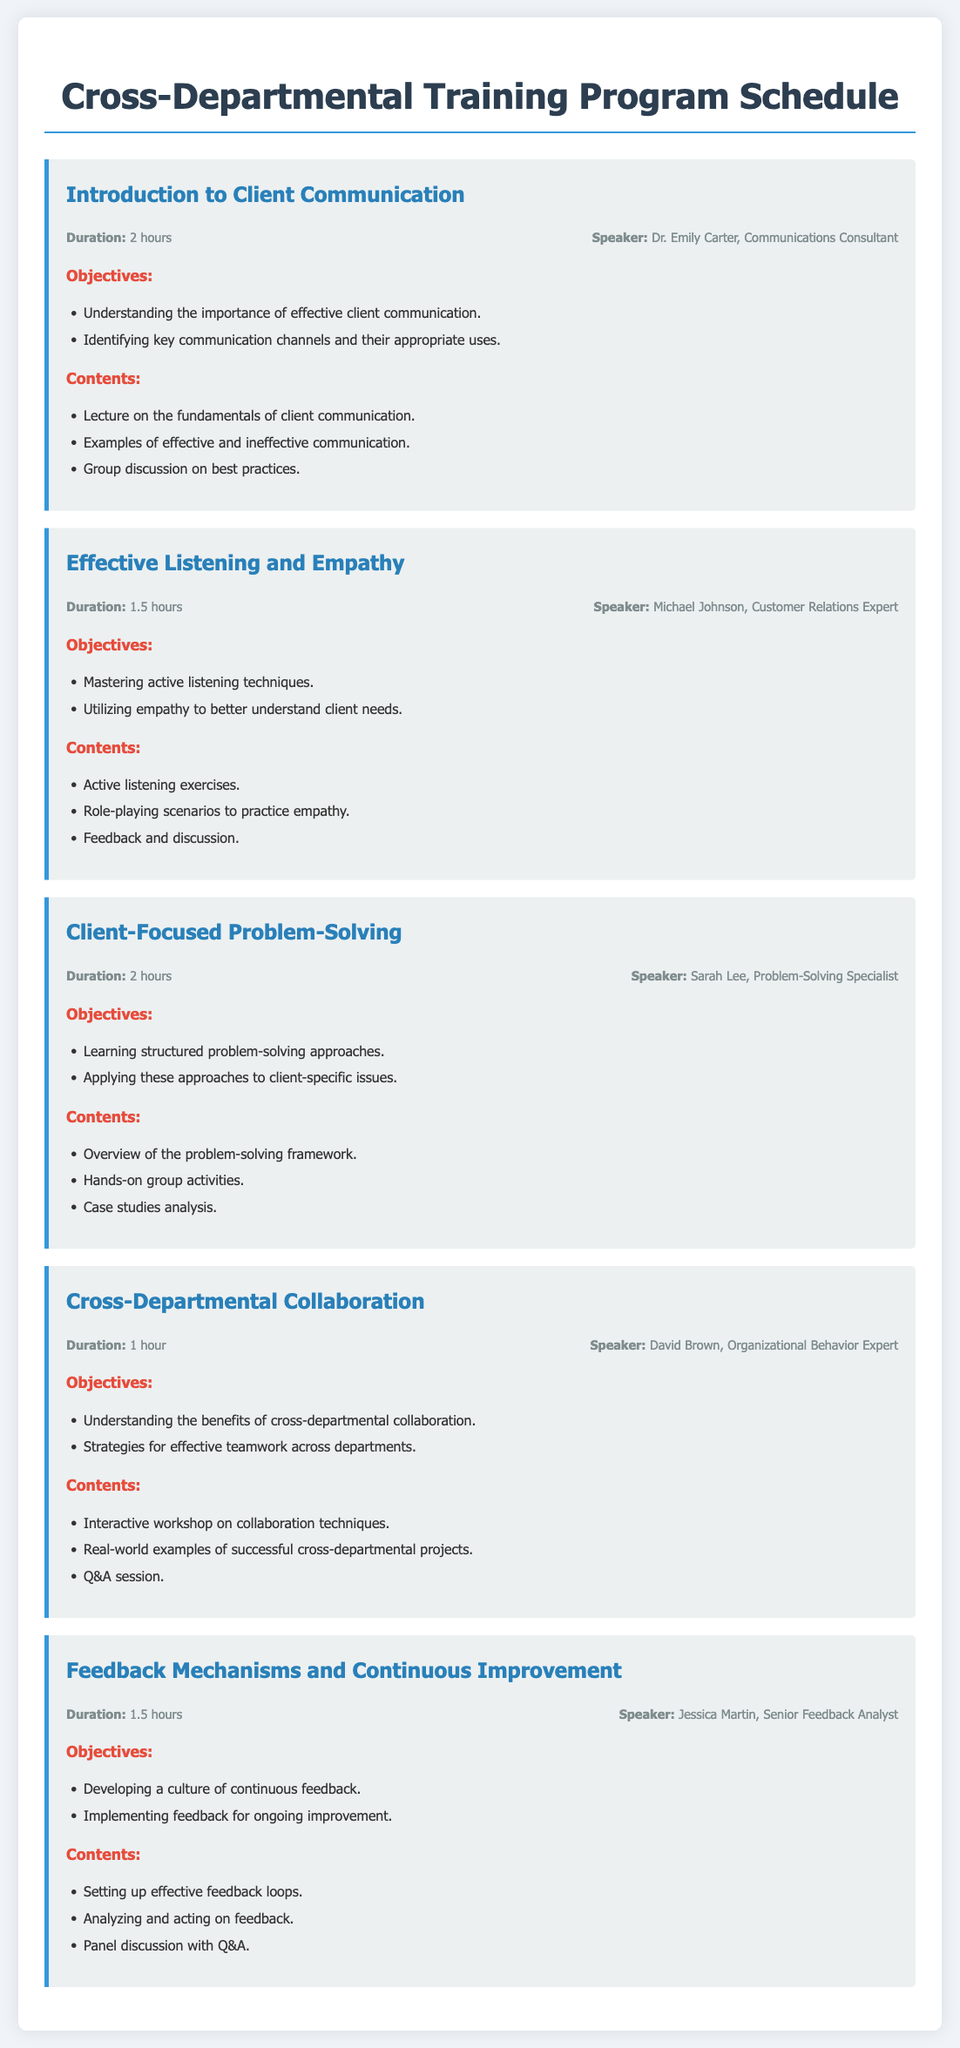What is the duration of the "Introduction to Client Communication" session? The duration of the session is specified in the document under the session's information.
Answer: 2 hours Who is the speaker for the "Effective Listening and Empathy" session? The speaker's name is mentioned in the session's information section.
Answer: Michael Johnson What type of exercises are included in the "Client-Focused Problem-Solving" session? The contents section outlines the activities included in the session.
Answer: Hands-on group activities What is one of the objectives of the "Cross-Departmental Collaboration" session? The objectives section lists the goals for this session.
Answer: Understanding the benefits of cross-departmental collaboration How long is the "Feedback Mechanisms and Continuous Improvement" session? The session duration is provided in its session information.
Answer: 1.5 hours Name one of the contents discussed in the "Introduction to Client Communication" session. The contents section describes various topics covered in the session.
Answer: Lecture on the fundamentals of client communication What is the total number of sessions in this training program? The number of sessions can be counted by looking at each session described in the document.
Answer: 5 sessions Which session focuses on "Mastering active listening techniques"? The titles of the sessions can be referenced to find the correct session.
Answer: Effective Listening and Empathy Who specializes in client communication among the listed speakers? The speaker's expertise is detailed in the session information.
Answer: Dr. Emily Carter 